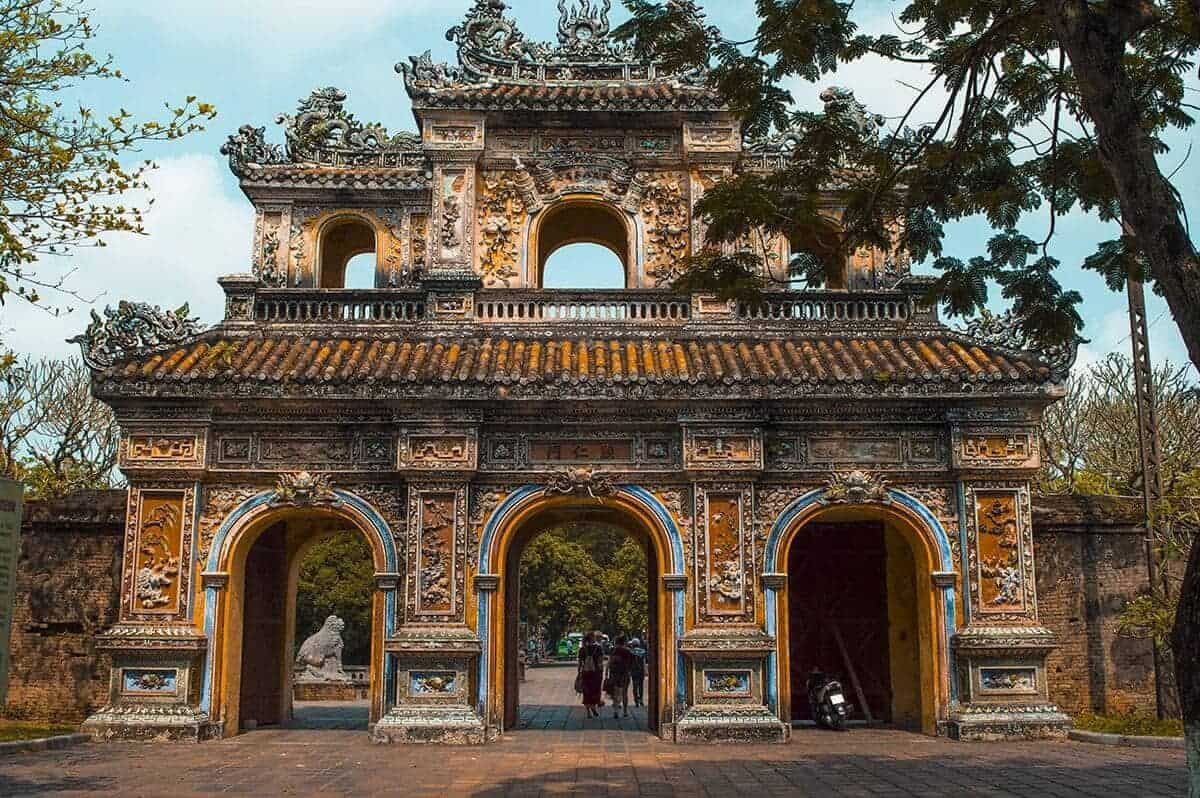Can you describe the main features of this image for me? The image showcases the grandeur of the Imperial Citadel in Hue, Vietnam. The focal point is the exquisite gateway, epitomizing traditional Vietnamese architecture. This gateway, known as a 'Ngo Mon', serves as the main entrance and is marked by three symmetrical arches with the central one, used exclusively by the emperor, being significantly taller. This central arch is flanked by two smaller ones, used by mandarins and royal guards. The gate's facade is richly decorated with intricate relief sculptures depicting dragons, typical symbols of imperial power and protection in Vietnamese culture. The surface is adorned with colorful ceramic tiles that create vibrant, detailed patterns - a testament to the craftsmanship of the period. The gateway is framed by aged stone walls and guarded by stone lion statues, symbolic guards to the sovereignty within. Lush greenery surrounds the structure, contrasting with the warm tones of the gate and adding a serene atmosphere to the commanding historical site. The citadel, a UNESCO World Heritage Site, once served as a fortress and a royal palace, and today, it stands as a proud reminder of the rich cultural and historical tapestry of Vietnam. People walking through its gates get a tangible sense of history as they step onto grounds walked by generations of royalty. 